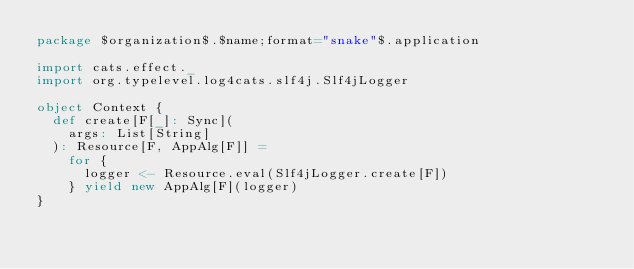Convert code to text. <code><loc_0><loc_0><loc_500><loc_500><_Scala_>package $organization$.$name;format="snake"$.application

import cats.effect._
import org.typelevel.log4cats.slf4j.Slf4jLogger

object Context {
  def create[F[_]: Sync](
    args: List[String]
  ): Resource[F, AppAlg[F]] =
    for {
      logger <- Resource.eval(Slf4jLogger.create[F])
    } yield new AppAlg[F](logger)
}
</code> 